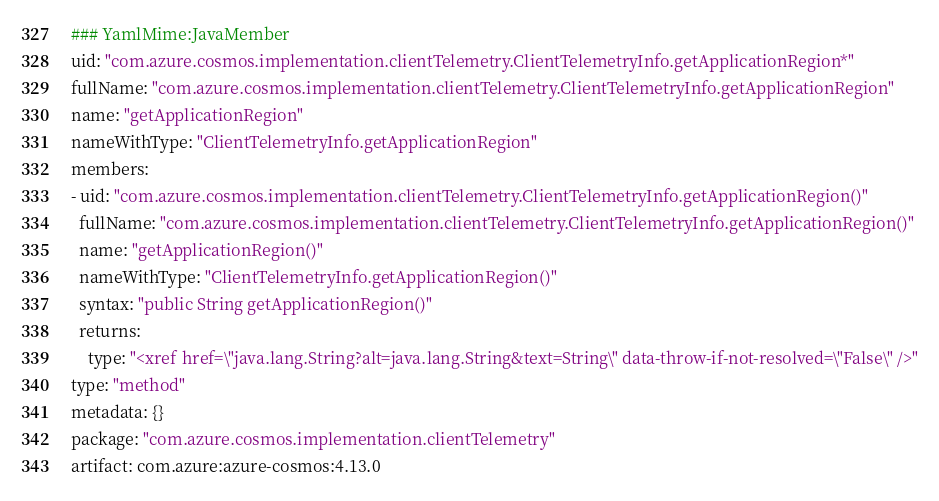<code> <loc_0><loc_0><loc_500><loc_500><_YAML_>### YamlMime:JavaMember
uid: "com.azure.cosmos.implementation.clientTelemetry.ClientTelemetryInfo.getApplicationRegion*"
fullName: "com.azure.cosmos.implementation.clientTelemetry.ClientTelemetryInfo.getApplicationRegion"
name: "getApplicationRegion"
nameWithType: "ClientTelemetryInfo.getApplicationRegion"
members:
- uid: "com.azure.cosmos.implementation.clientTelemetry.ClientTelemetryInfo.getApplicationRegion()"
  fullName: "com.azure.cosmos.implementation.clientTelemetry.ClientTelemetryInfo.getApplicationRegion()"
  name: "getApplicationRegion()"
  nameWithType: "ClientTelemetryInfo.getApplicationRegion()"
  syntax: "public String getApplicationRegion()"
  returns:
    type: "<xref href=\"java.lang.String?alt=java.lang.String&text=String\" data-throw-if-not-resolved=\"False\" />"
type: "method"
metadata: {}
package: "com.azure.cosmos.implementation.clientTelemetry"
artifact: com.azure:azure-cosmos:4.13.0
</code> 